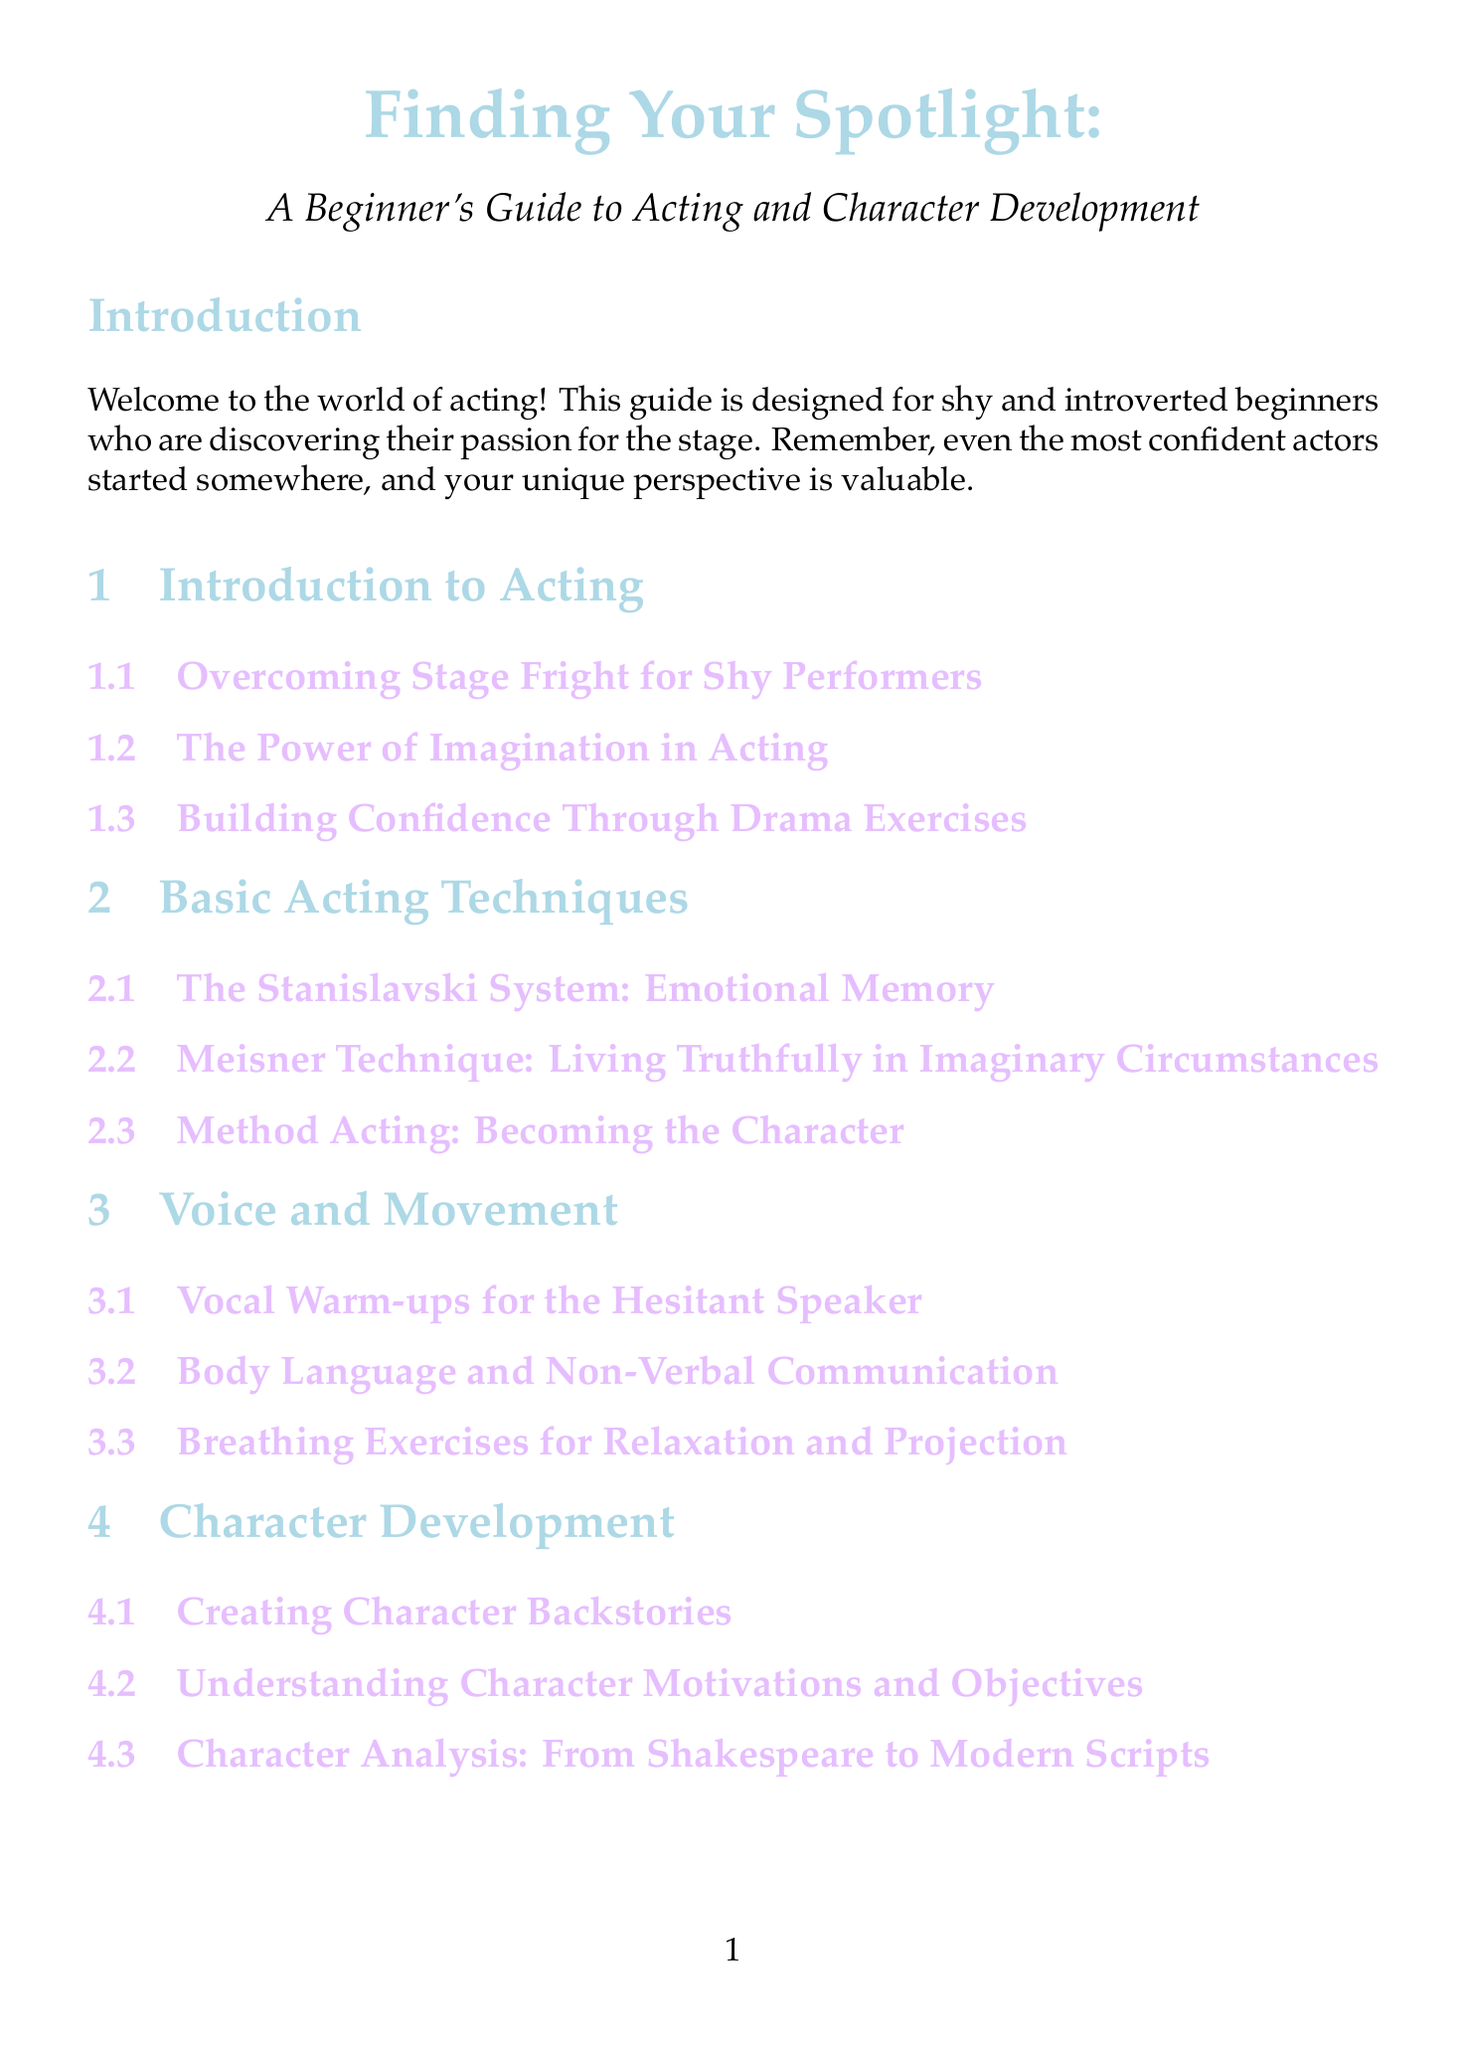What is the title of the manual? The title is the main heading of the document, which introduces the guide for beginners.
Answer: Finding Your Spotlight: A Beginner's Guide to Acting and Character Development How many chapters are there in the manual? The number of chapters can be counted in the table of contents section of the document.
Answer: Ten What is one technique discussed in the Basic Acting Techniques chapter? This question looks for a specific technique mentioned in the corresponding chapter.
Answer: Method Acting What exercise helps build self-awareness and confidence? The exercise section includes various activities aimed at improving acting skills, including this specific exercise.
Answer: Mirror Work Who wrote "The Actor's Life: A Survival Guide"? This question seeks the author of a specific book listed in the resources section.
Answer: Jenna Fischer In which section can you find tips on audition etiquette? The question targets specific information regarding the preparation for auditions mentioned in a designated chapter.
Answer: Audition Preparation What type of resource is "Inside the Actors Studio"? This question identifies the category of media related to the resource provided in the document.
Answer: TV Series Which acting technique involves emotional memory? This question references a specific method outlined in the relevant chapter on acting techniques.
Answer: The Stanislavski System What is a key topic in the Self-Care for Actors section? This question aims to find a significant subject covered in the self-care section of the manual.
Answer: Managing Performance Anxiety What do improvisation techniques enhance? This question looks into the purpose of specific techniques outlined in the Script Analysis chapter.
Answer: Scripted Performances 